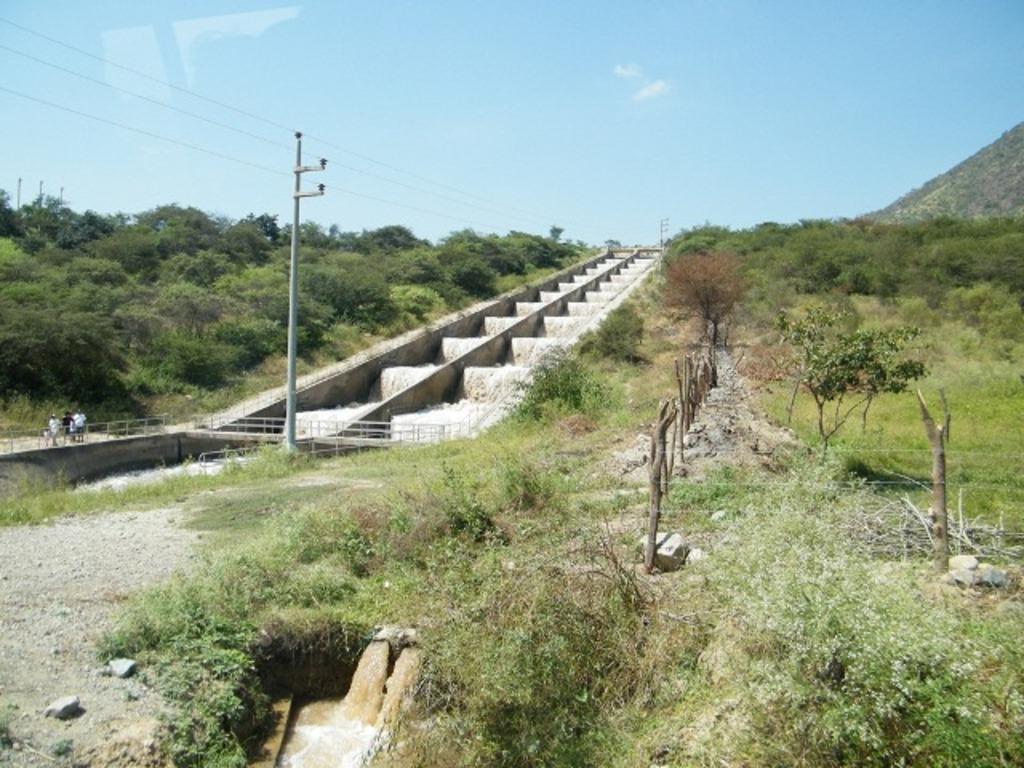Describe this image in one or two sentences. There is water fall from the pipes into the small lake near the grass and plants which are on the ground. In the background, there is water fall on the steps, there is grass, plants and trees on the hill, there are persons on the road, there is mountain and there are clouds in the blue sky. 